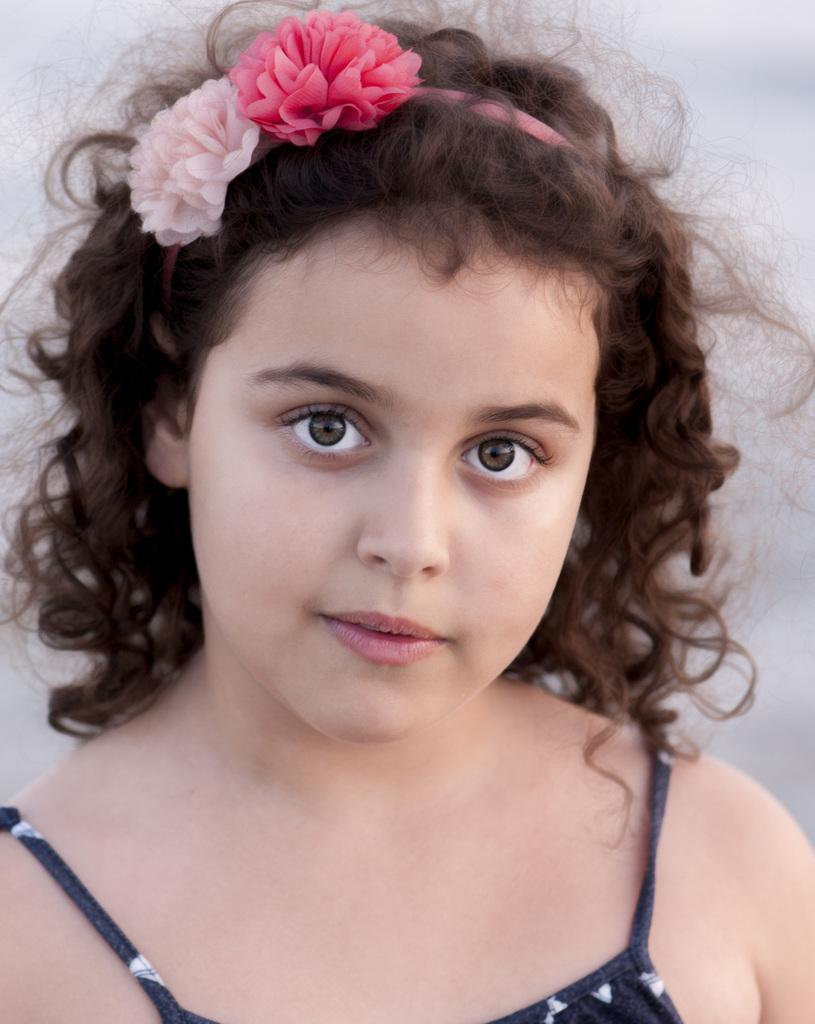Who is the main subject in the image? There is a girl in the image. What is the girl wearing? The girl is wearing a black dress. Are there any accessories visible on the girl? Yes, the girl has a headband on her head. How would you describe the background of the image? The background of the image is blurred. Are there any dogs in the image? No, there are no dogs present in the image. Is there any smoke visible in the image? No, there is no smoke visible in the image. 